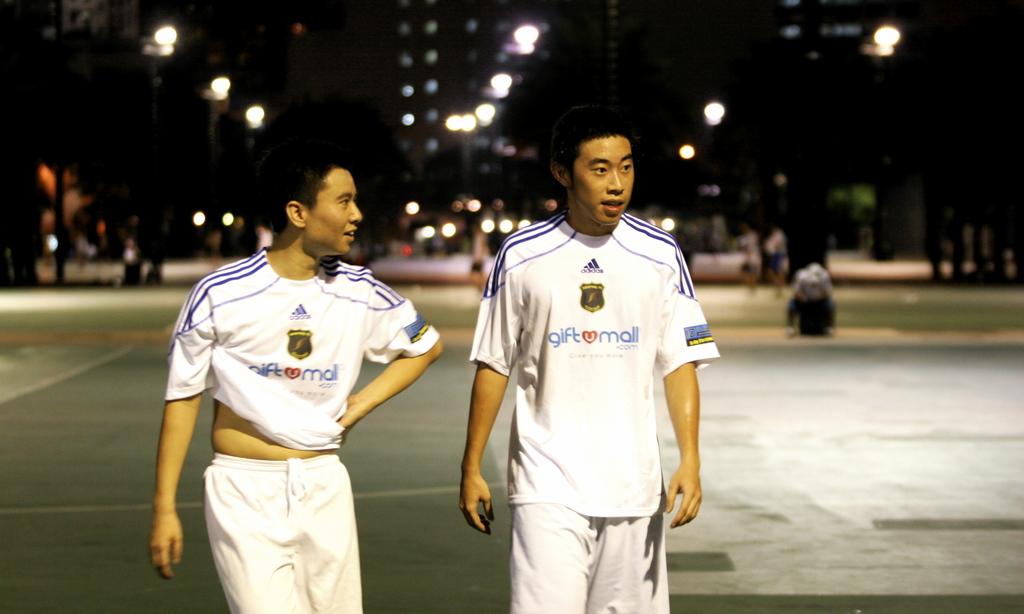Who is the sponsor for this team?
Provide a short and direct response. Gift mall. 